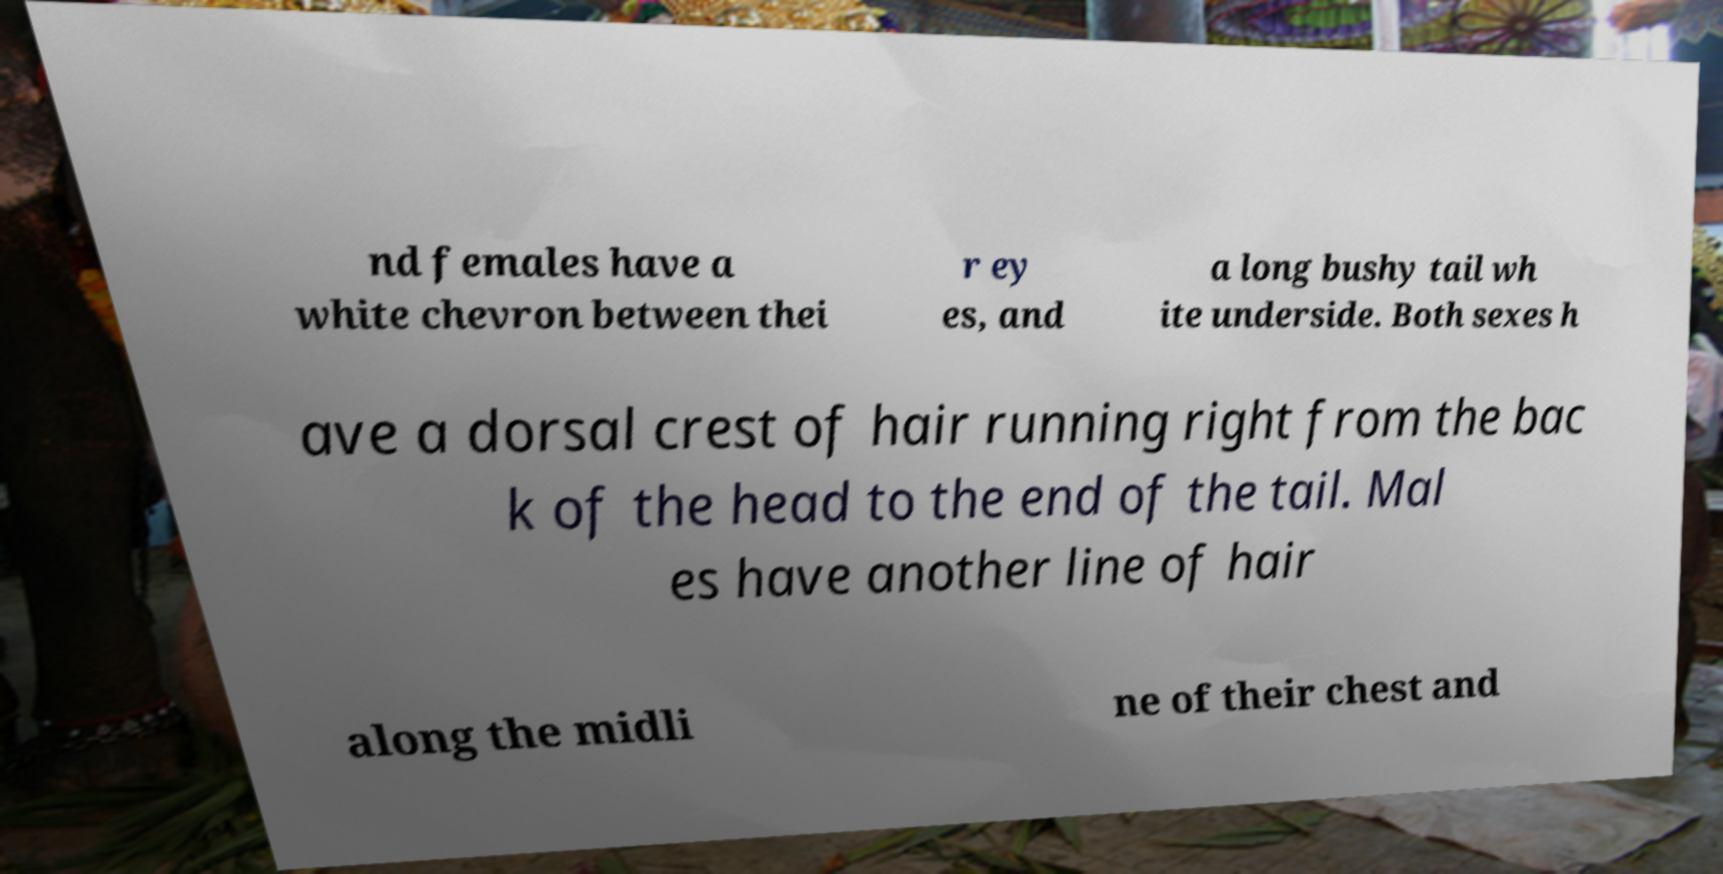Can you read and provide the text displayed in the image?This photo seems to have some interesting text. Can you extract and type it out for me? nd females have a white chevron between thei r ey es, and a long bushy tail wh ite underside. Both sexes h ave a dorsal crest of hair running right from the bac k of the head to the end of the tail. Mal es have another line of hair along the midli ne of their chest and 